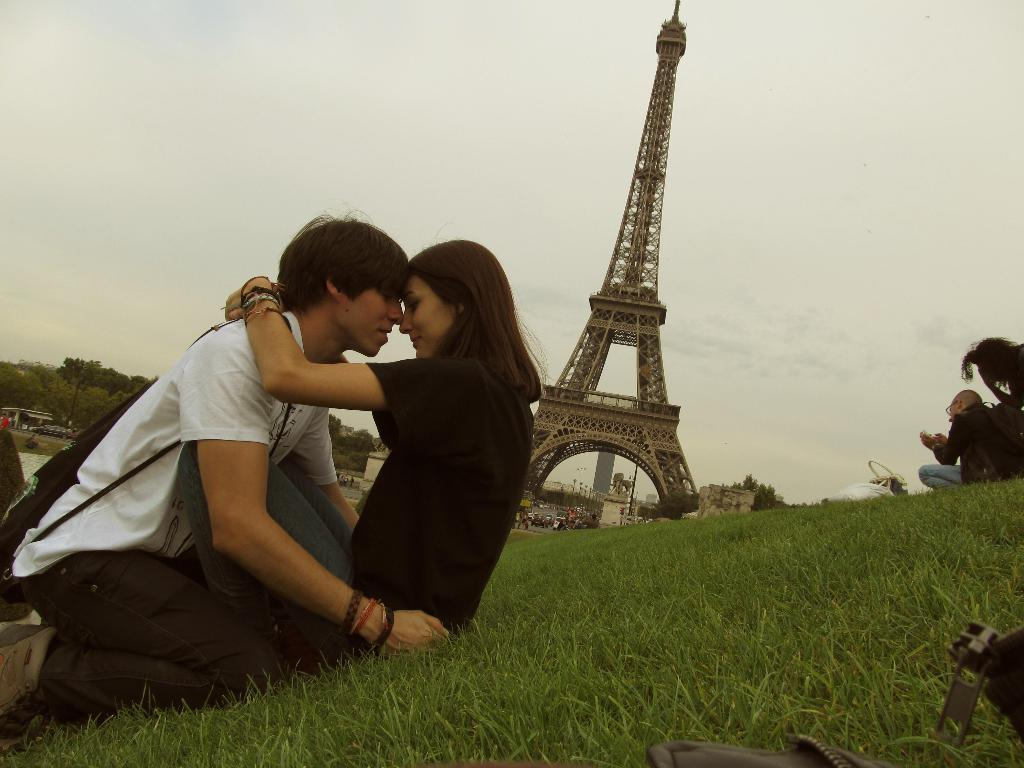What type of vegetation is present on the ground in the front of the image? There is grass on the ground in the front of the image. What can be seen in the center of the image? There are persons in the center of the image. What structures are visible in the background of the image? There is a tower, trees, and buildings in the background of the image. What is the condition of the sky in the background of the image? The sky is cloudy in the background of the image. Are the sisters in the image visiting the hospital? There is no mention of sisters or a hospital in the image. How many floors can be seen in the lift in the image? There is no lift present in the image. 